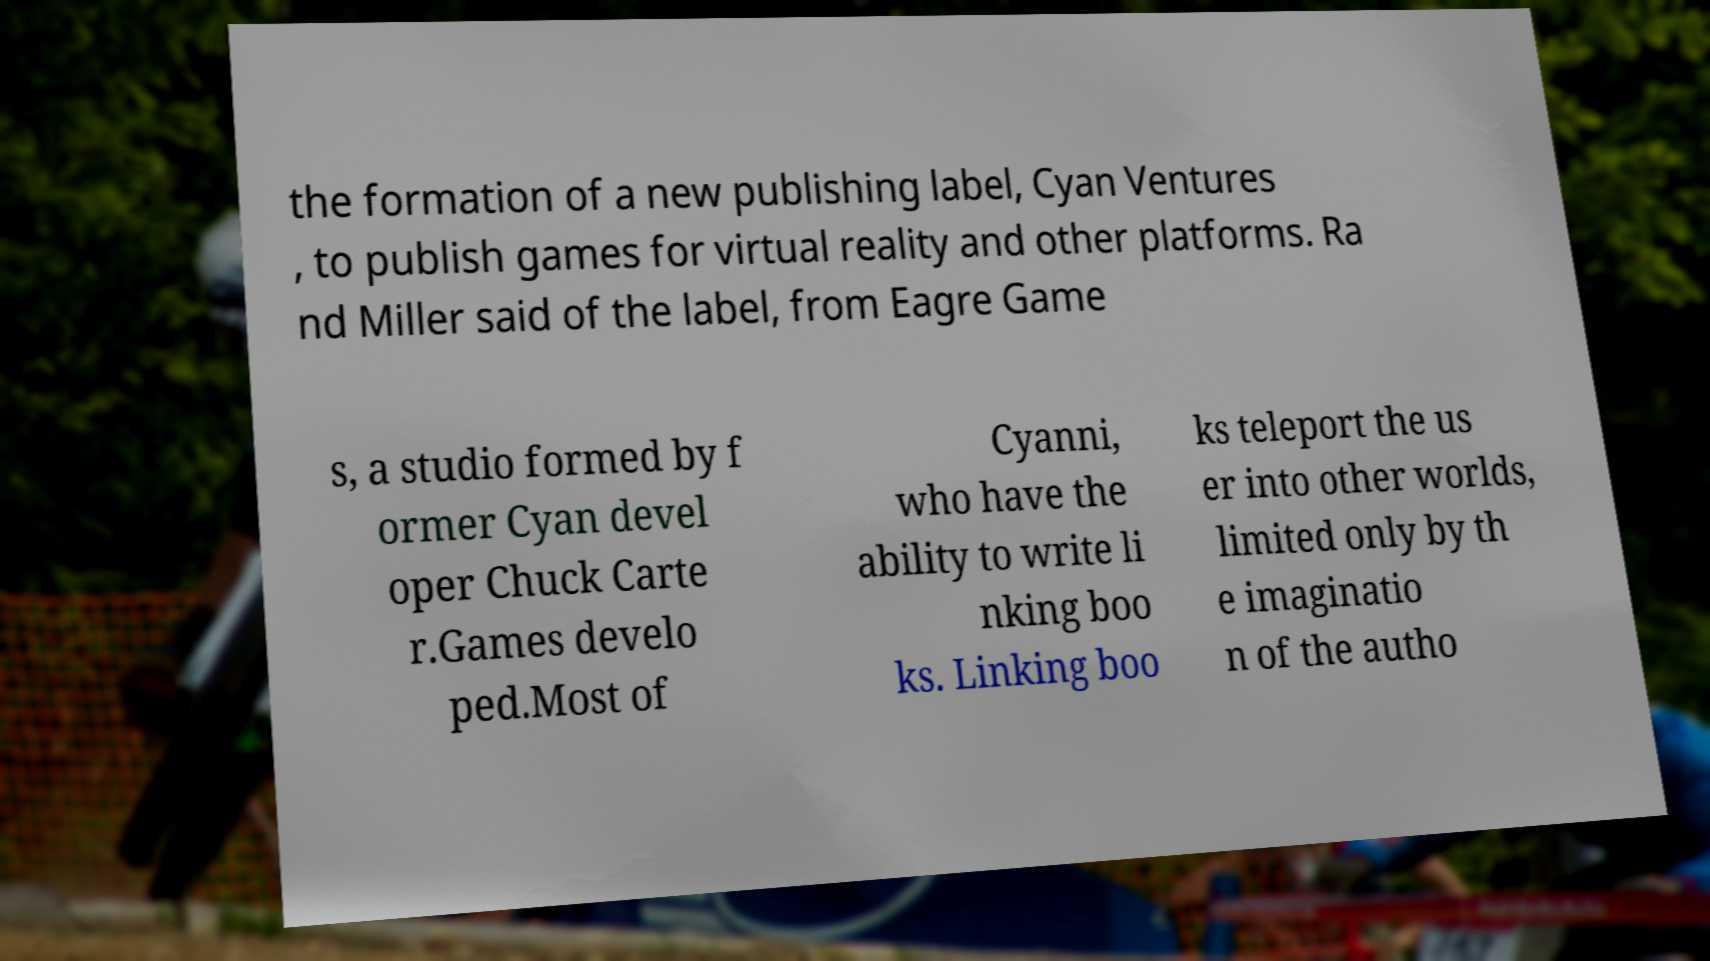What messages or text are displayed in this image? I need them in a readable, typed format. the formation of a new publishing label, Cyan Ventures , to publish games for virtual reality and other platforms. Ra nd Miller said of the label, from Eagre Game s, a studio formed by f ormer Cyan devel oper Chuck Carte r.Games develo ped.Most of Cyanni, who have the ability to write li nking boo ks. Linking boo ks teleport the us er into other worlds, limited only by th e imaginatio n of the autho 